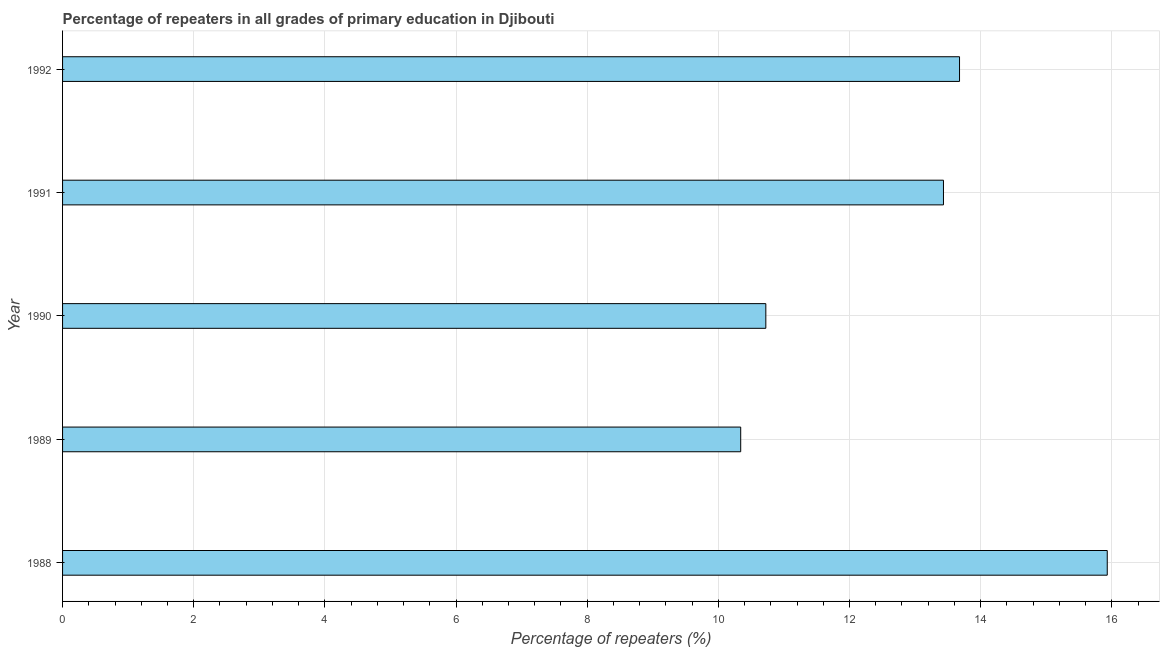What is the title of the graph?
Your answer should be very brief. Percentage of repeaters in all grades of primary education in Djibouti. What is the label or title of the X-axis?
Keep it short and to the point. Percentage of repeaters (%). What is the percentage of repeaters in primary education in 1992?
Make the answer very short. 13.68. Across all years, what is the maximum percentage of repeaters in primary education?
Keep it short and to the point. 15.93. Across all years, what is the minimum percentage of repeaters in primary education?
Ensure brevity in your answer.  10.34. In which year was the percentage of repeaters in primary education maximum?
Offer a very short reply. 1988. In which year was the percentage of repeaters in primary education minimum?
Provide a succinct answer. 1989. What is the sum of the percentage of repeaters in primary education?
Provide a short and direct response. 64.11. What is the difference between the percentage of repeaters in primary education in 1990 and 1992?
Your answer should be compact. -2.95. What is the average percentage of repeaters in primary education per year?
Your answer should be compact. 12.82. What is the median percentage of repeaters in primary education?
Give a very brief answer. 13.43. Do a majority of the years between 1990 and 1989 (inclusive) have percentage of repeaters in primary education greater than 8.8 %?
Ensure brevity in your answer.  No. What is the ratio of the percentage of repeaters in primary education in 1990 to that in 1991?
Your answer should be compact. 0.8. Is the difference between the percentage of repeaters in primary education in 1990 and 1992 greater than the difference between any two years?
Offer a very short reply. No. What is the difference between the highest and the second highest percentage of repeaters in primary education?
Keep it short and to the point. 2.25. Is the sum of the percentage of repeaters in primary education in 1988 and 1990 greater than the maximum percentage of repeaters in primary education across all years?
Your answer should be compact. Yes. What is the difference between the highest and the lowest percentage of repeaters in primary education?
Your response must be concise. 5.59. How many bars are there?
Offer a terse response. 5. Are all the bars in the graph horizontal?
Give a very brief answer. Yes. What is the difference between two consecutive major ticks on the X-axis?
Offer a very short reply. 2. What is the Percentage of repeaters (%) in 1988?
Offer a terse response. 15.93. What is the Percentage of repeaters (%) of 1989?
Your answer should be very brief. 10.34. What is the Percentage of repeaters (%) of 1990?
Provide a short and direct response. 10.72. What is the Percentage of repeaters (%) of 1991?
Offer a very short reply. 13.43. What is the Percentage of repeaters (%) of 1992?
Keep it short and to the point. 13.68. What is the difference between the Percentage of repeaters (%) in 1988 and 1989?
Your answer should be compact. 5.59. What is the difference between the Percentage of repeaters (%) in 1988 and 1990?
Provide a short and direct response. 5.21. What is the difference between the Percentage of repeaters (%) in 1988 and 1991?
Your answer should be very brief. 2.5. What is the difference between the Percentage of repeaters (%) in 1988 and 1992?
Your answer should be very brief. 2.25. What is the difference between the Percentage of repeaters (%) in 1989 and 1990?
Give a very brief answer. -0.38. What is the difference between the Percentage of repeaters (%) in 1989 and 1991?
Your answer should be very brief. -3.09. What is the difference between the Percentage of repeaters (%) in 1989 and 1992?
Provide a succinct answer. -3.34. What is the difference between the Percentage of repeaters (%) in 1990 and 1991?
Provide a short and direct response. -2.71. What is the difference between the Percentage of repeaters (%) in 1990 and 1992?
Your answer should be compact. -2.95. What is the difference between the Percentage of repeaters (%) in 1991 and 1992?
Keep it short and to the point. -0.24. What is the ratio of the Percentage of repeaters (%) in 1988 to that in 1989?
Provide a succinct answer. 1.54. What is the ratio of the Percentage of repeaters (%) in 1988 to that in 1990?
Keep it short and to the point. 1.49. What is the ratio of the Percentage of repeaters (%) in 1988 to that in 1991?
Keep it short and to the point. 1.19. What is the ratio of the Percentage of repeaters (%) in 1988 to that in 1992?
Offer a terse response. 1.17. What is the ratio of the Percentage of repeaters (%) in 1989 to that in 1991?
Your answer should be compact. 0.77. What is the ratio of the Percentage of repeaters (%) in 1989 to that in 1992?
Provide a succinct answer. 0.76. What is the ratio of the Percentage of repeaters (%) in 1990 to that in 1991?
Offer a terse response. 0.8. What is the ratio of the Percentage of repeaters (%) in 1990 to that in 1992?
Offer a very short reply. 0.78. 